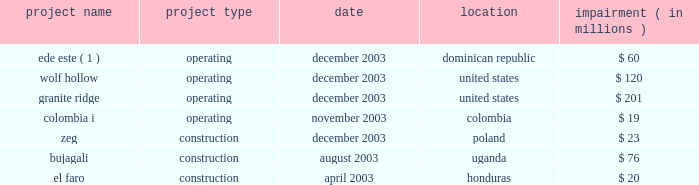We cannot assure you that the gener restructuring will be completed or that the terms thereof will not be changed materially .
In addition , gener is in the process of restructuring the debt of its subsidiaries , termoandes s.a .
( 2018 2018termoandes 2019 2019 ) and interandes , s.a .
( 2018 2018interandes 2019 2019 ) , and expects that the maturities of these obligations will be extended .
Under-performing businesses during 2003 we sold or discontinued under-performing businesses and construction projects that did not meet our investment criteria or did not provide reasonable opportunities to restructure .
It is anticipated that there will be less ongoing activity related to write-offs of development or construction projects and impairment charges in the future .
The businesses , which were affected in 2003 , are listed below .
Impairment project name project type date location ( in millions ) .
( 1 ) see note 4 2014discontinued operations .
Improving credit quality our de-leveraging efforts reduced parent level debt by $ 1.2 billion in 2003 ( including the secured equity-linked loan previously issued by aes new york funding l.l.c. ) .
We refinanced and paid down near-term maturities by $ 3.5 billion and enhanced our year-end liquidity to over $ 1 billion .
Our average debt maturity was extended from 2009 to 2012 .
At the subsidiary level we continue to pursue limited recourse financing to reduce parent credit risk .
These factors resulted in an overall reduced cost of capital , improved credit statistics and expanded access to credit at both aes and our subsidiaries .
Liquidity at the aes parent level is an important factor for the rating agencies in determining whether the company 2019s credit quality should improve .
Currency and political risk tend to be biggest variables to sustaining predictable cash flow .
The nature of our large contractual and concession-based cash flow from these businesses serves to mitigate these variables .
In 2003 , over 81% ( 81 % ) of cash distributions to the parent company were from u.s .
Large utilities and worldwide contract generation .
On february 4 , 2004 , we called for redemption of $ 155049000 aggregate principal amount of outstanding 8% ( 8 % ) senior notes due 2008 , which represents the entire outstanding principal amount of the 8% ( 8 % ) senior notes due 2008 , and $ 34174000 aggregate principal amount of outstanding 10% ( 10 % ) secured senior notes due 2005 .
The 8% ( 8 % ) senior notes due 2008 and the 10% ( 10 % ) secured senior notes due 2005 were redeemed on march 8 , 2004 at a redemption price equal to 100% ( 100 % ) of the principal amount plus accrued and unpaid interest to the redemption date .
The mandatory redemption of the 10% ( 10 % ) secured senior notes due 2005 was being made with a portion of our 2018 2018adjusted free cash flow 2019 2019 ( as defined in the indenture pursuant to which the notes were issued ) for the fiscal year ended december 31 , 2003 as required by the indenture and was made on a pro rata basis .
On february 13 , 2004 we issued $ 500 million of unsecured senior notes .
The unsecured senior notes mature on march 1 , 2014 and are callable at our option at any time at a redemption price equal to 100% ( 100 % ) of the principal amount of the unsecured senior notes plus a make-whole premium .
The unsecured senior notes were issued at a price of 98.288% ( 98.288 % ) and pay interest semi-annually at an annual .
What was the total in millions of impairment projects in the construction category in 2003? 
Computations: ((23 + 76) + 20)
Answer: 119.0. 